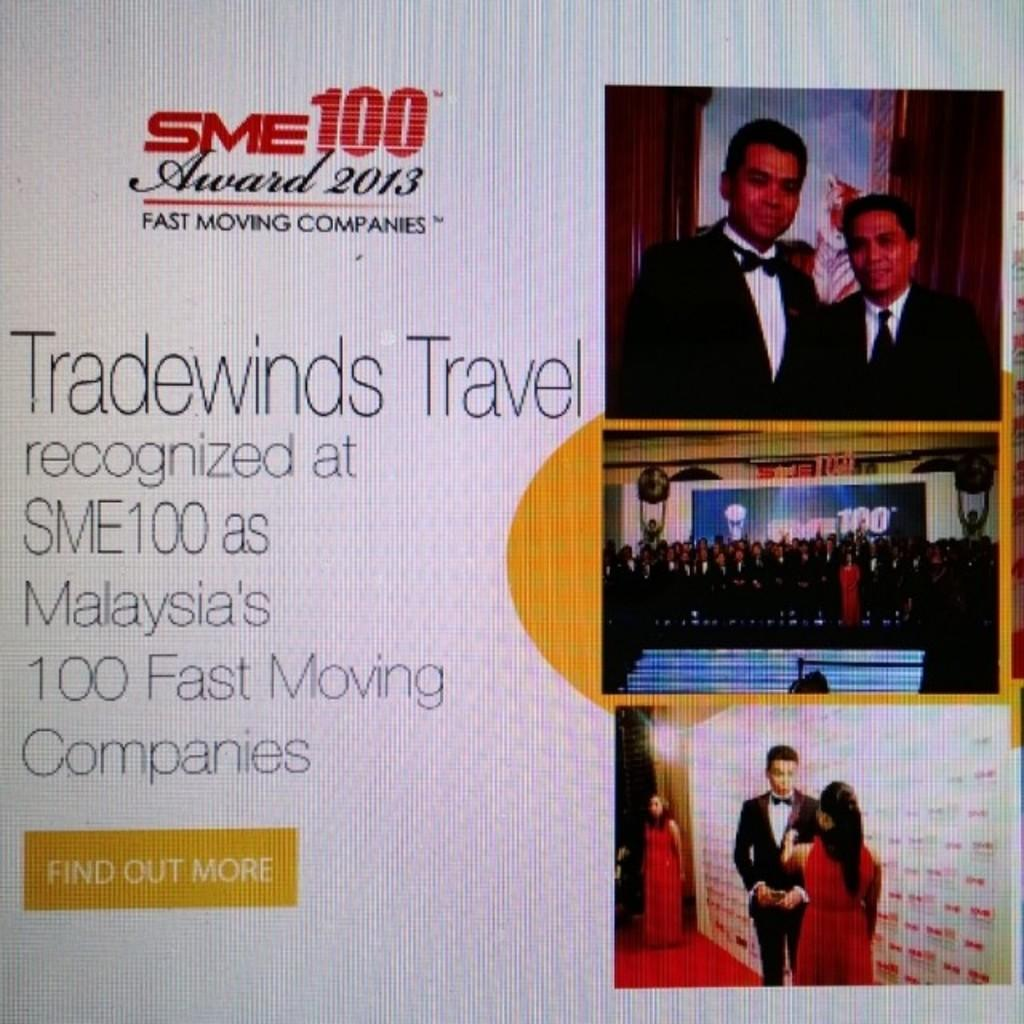What type of image is being described? The image is a screen. What can be found on the left side of the screen? There are texts written on the left side of the screen. What is located on the right side of the screen? There are pictures on the right side of the screen. Are there any branches visible in the image? There is no mention of branches in the provided facts, so it cannot be determined if any are present in the image. 